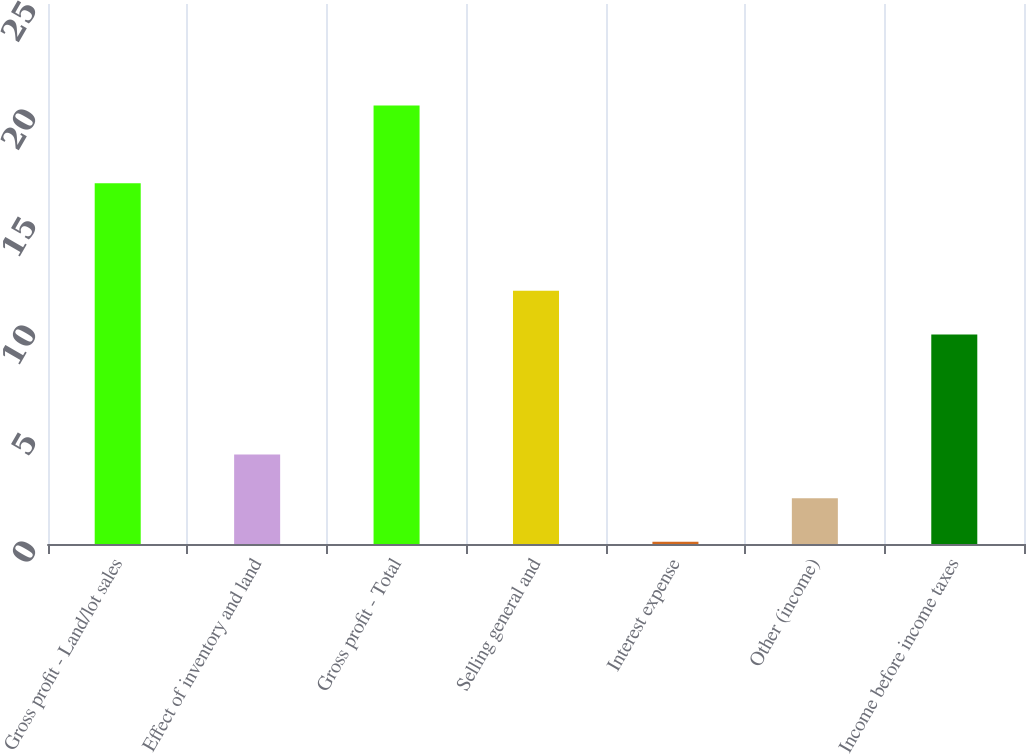Convert chart. <chart><loc_0><loc_0><loc_500><loc_500><bar_chart><fcel>Gross profit - Land/lot sales<fcel>Effect of inventory and land<fcel>Gross profit - Total<fcel>Selling general and<fcel>Interest expense<fcel>Other (income)<fcel>Income before income taxes<nl><fcel>16.7<fcel>4.14<fcel>20.3<fcel>11.72<fcel>0.1<fcel>2.12<fcel>9.7<nl></chart> 